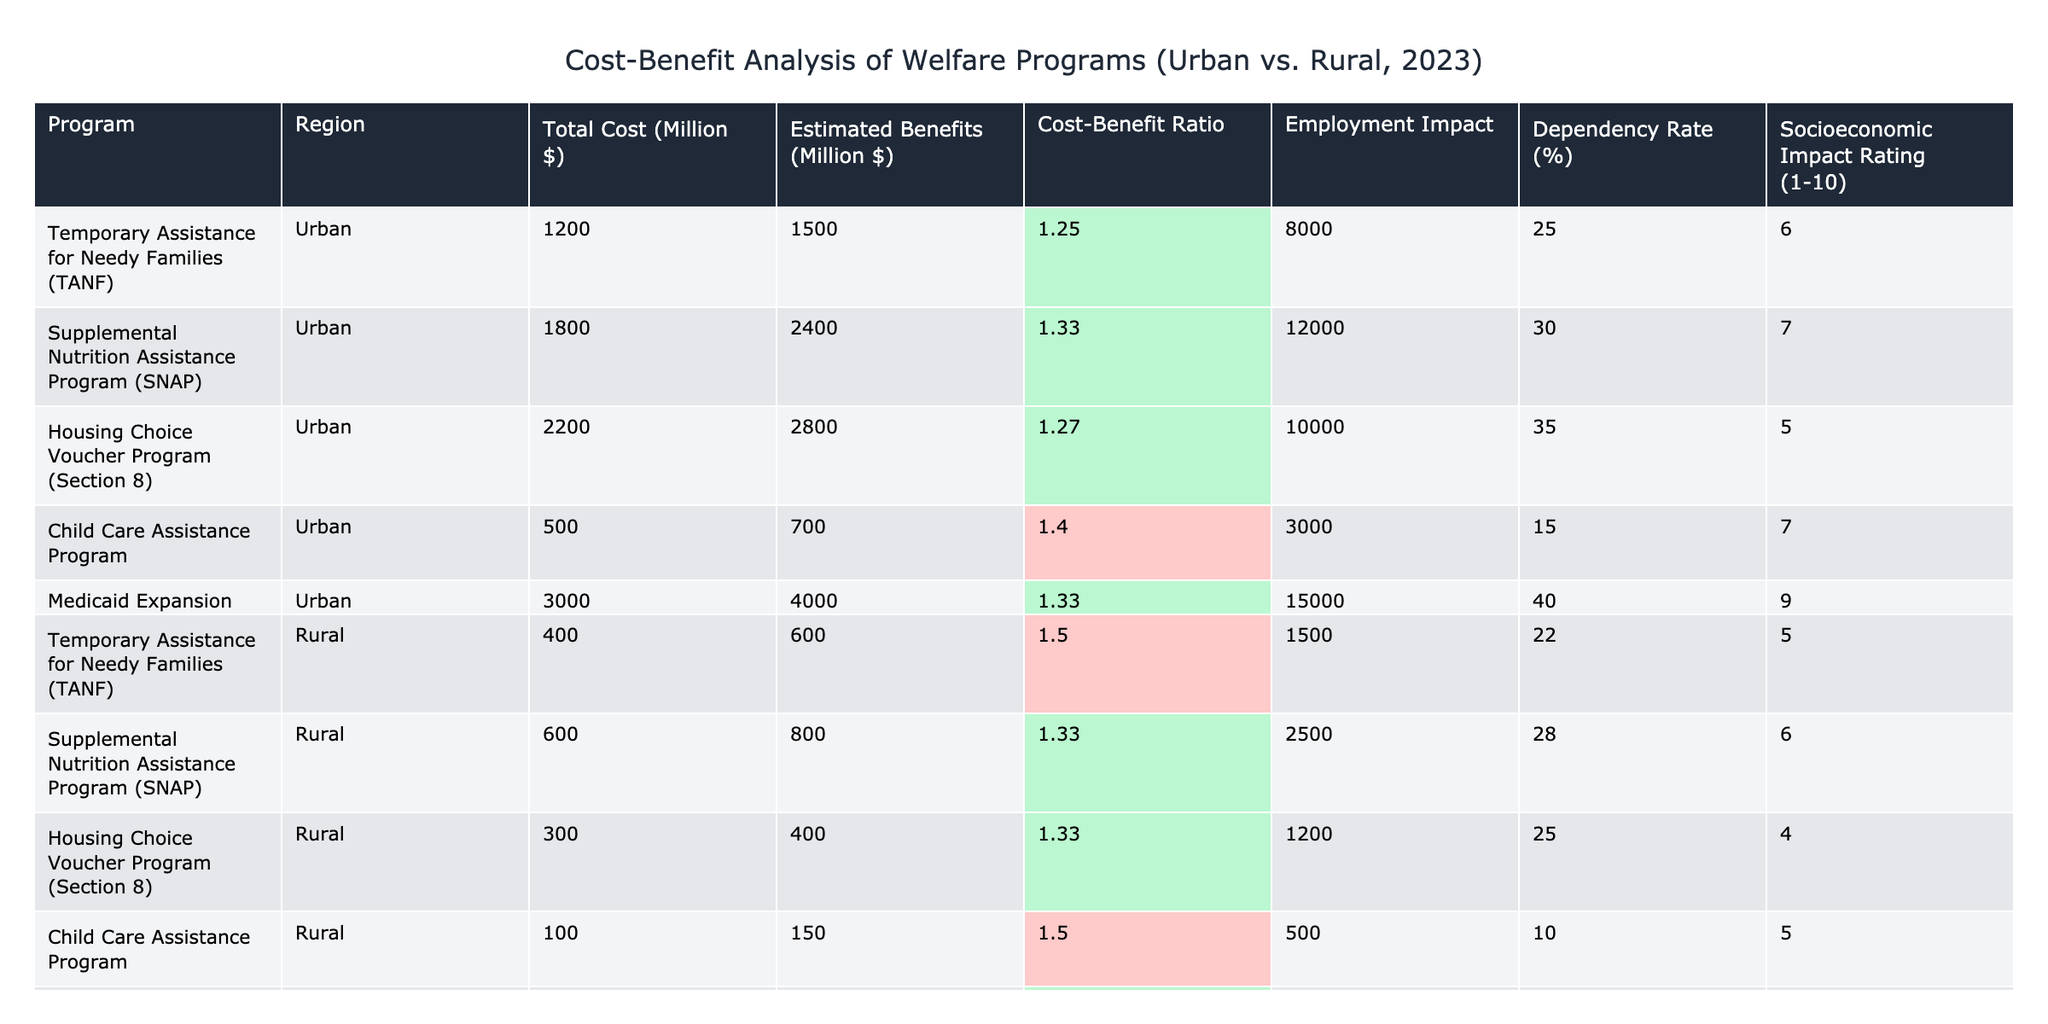What is the Cost-Benefit Ratio for the SNAP program in urban areas? The Cost-Benefit Ratio for the Supplemental Nutrition Assistance Program (SNAP) in urban areas is listed in the table as 1.33.
Answer: 1.33 What is the estimated benefit of the Medicaid Expansion in rural areas? The estimated benefits for the Medicaid Expansion program in rural areas can be found in the table, which states that it is 900 million dollars.
Answer: 900 million dollars Which welfare program has the highest total cost in urban areas? By examining the total cost column for urban areas, the program with the highest cost is the Medicaid Expansion, at 3000 million dollars.
Answer: Medicaid Expansion True or False: The Housing Choice Voucher Program in rural areas has a higher dependency rate than that in urban areas. The dependency rates for the Housing Choice Voucher Program are 25% in urban areas and 25% in rural areas, making this statement false as they are equal.
Answer: False What is the average cost-benefit ratio for all welfare programs in urban areas? The cost-benefit ratios for urban programs are: 1.25, 1.33, 1.27, 1.40, and 1.33. Adding these values yields 6.58, and dividing by 5 gives an average of 1.316.
Answer: 1.316 How much more employment impact does the SNAP program in urban areas have compared to the TANF program in rural areas? The employment impact for SNAP in urban areas is 12000, and for TANF in rural areas, it is 1500. The difference is calculated as 12000 - 1500 = 10500.
Answer: 10500 What percentage of the estimated benefits for the Child Care Assistance Program in urban areas is represented by the total cost? The estimated benefits for the Child Care Assistance Program in urban areas are 700 million dollars, and the total cost is 500 million dollars. To find the percentage, divide the total cost by estimated benefits: (500/700) * 100 = 71.43%.
Answer: 71.43% Which region has a higher socioeconomic impact rating for the Temporary Assistance for Needy Families program? The table shows that the socioeconomic impact rating for TANF in urban areas is 6, while in rural areas it is 5. Thus, urban areas have a higher rating.
Answer: Urban areas If we consider the Cost-Benefit Ratio, which program in rural areas is most efficient? The TANF program in rural areas has a Cost-Benefit Ratio of 1.50, which is the highest among the rural programs listed.
Answer: TANF 